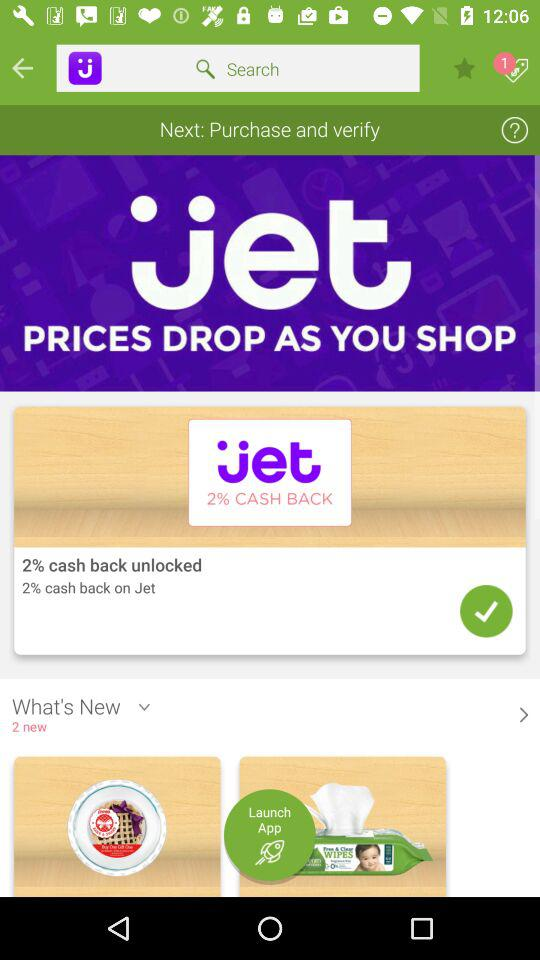How many percent cash back is offered on Jet?
Answer the question using a single word or phrase. 2% 